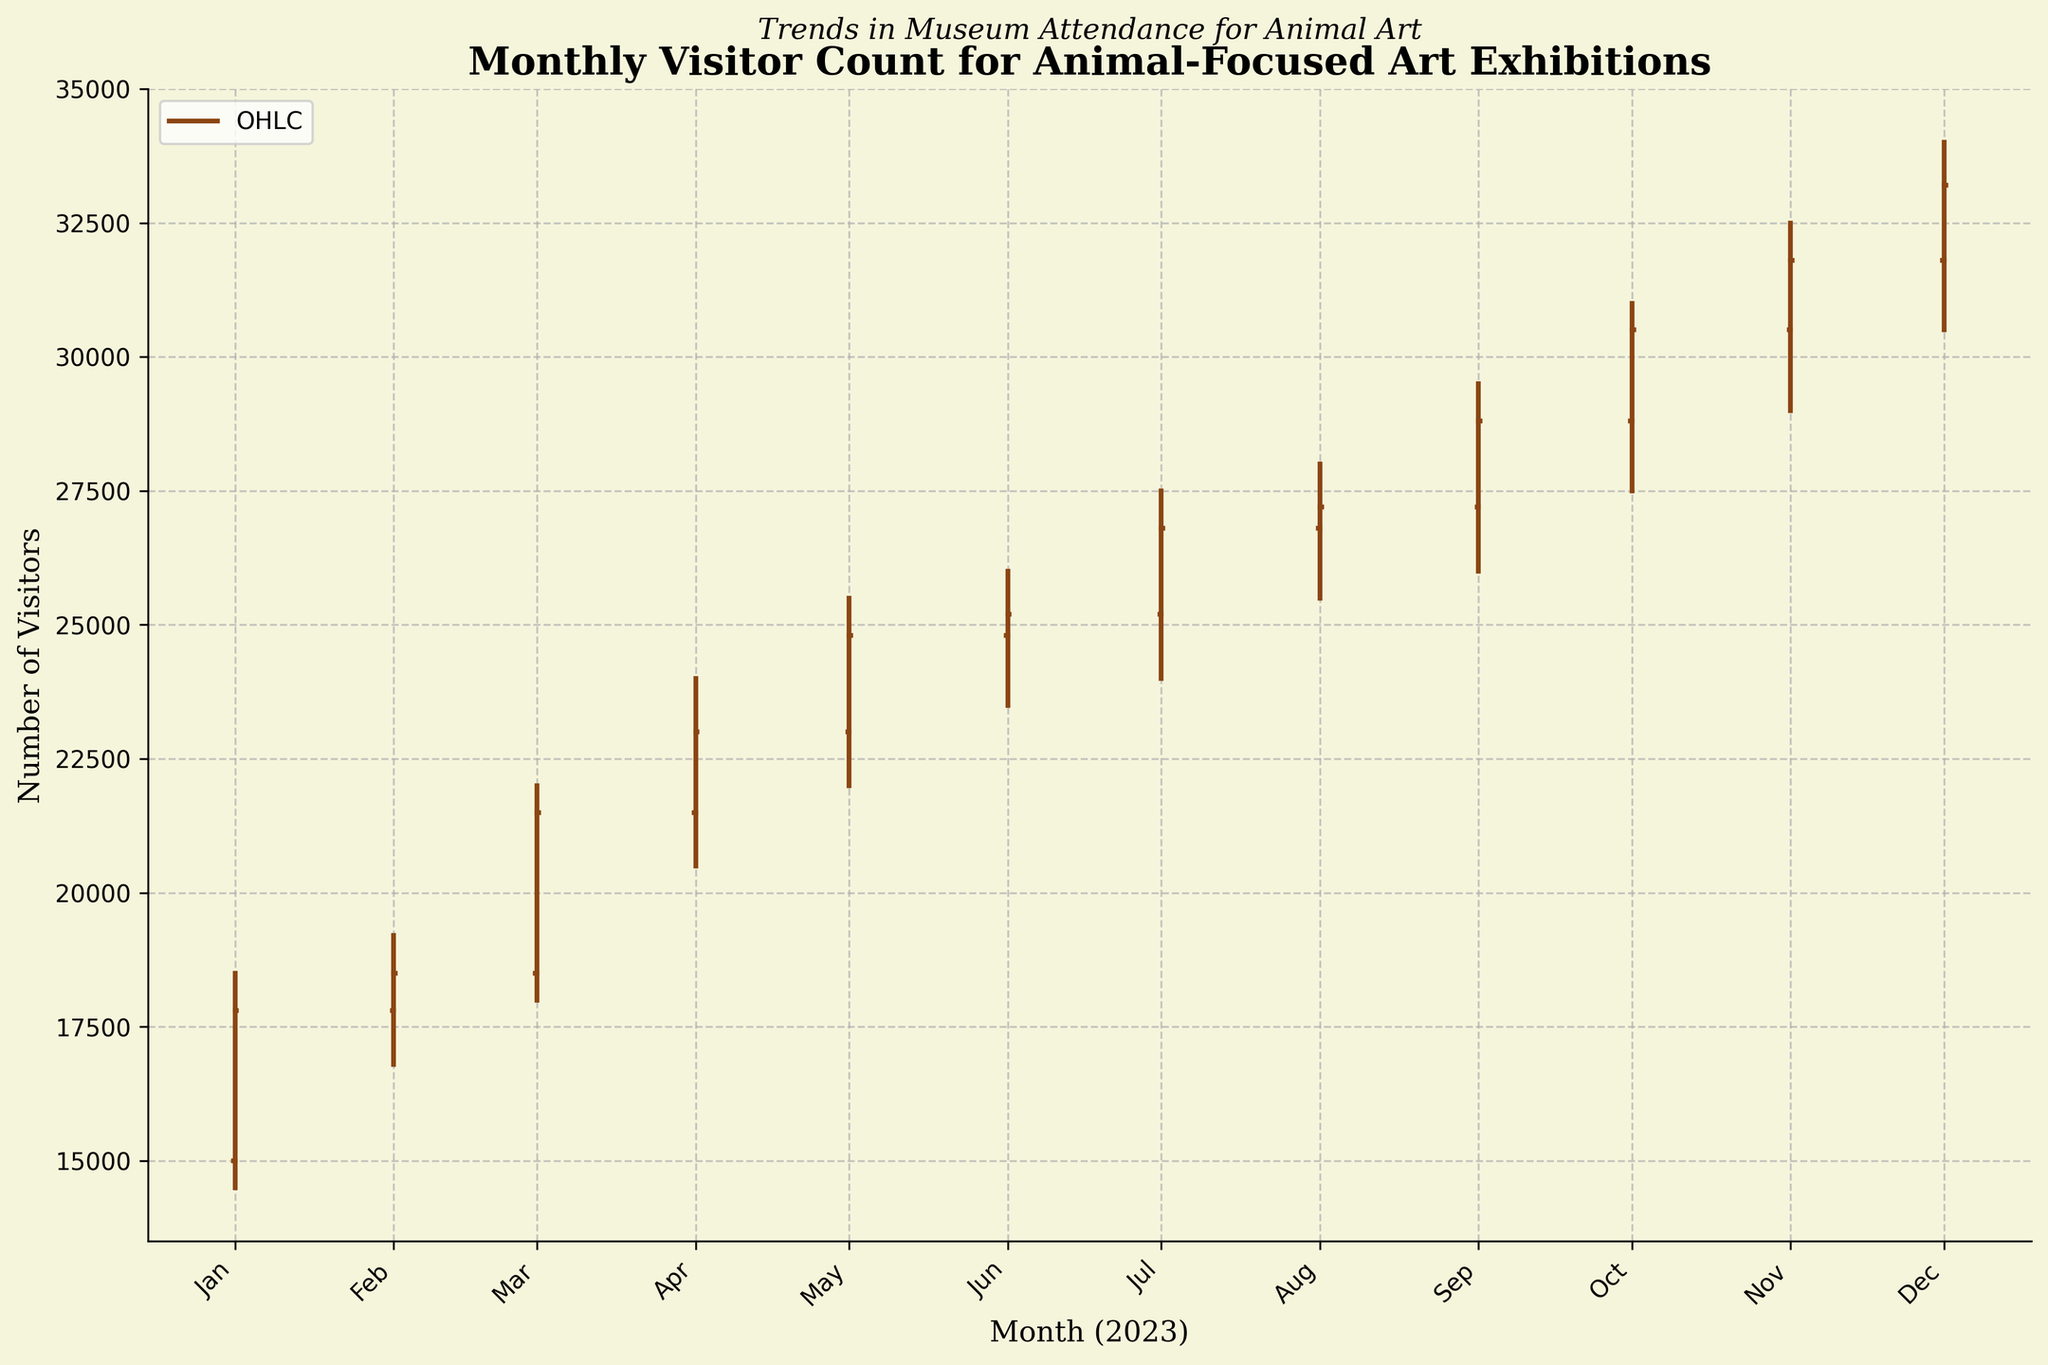What is the title of the figure? The title is usually displayed at the top of the figure, and it provides a brief description of what the figure represents. In this case, it is "Monthly Visitor Count for Animal-Focused Art Exhibitions".
Answer: Monthly Visitor Count for Animal-Focused Art Exhibitions What does the x-axis represent in the figure? The x-axis typically represents the time dimension in monthly OHLC charts. Here, it shows the months of the year 2023.
Answer: Month (2023) What is the highest visitor count recorded in the figure? To find the highest visitor count, look for the highest point in the 'High' column in the data, which corresponds to a High value of 34,000 in December 2023.
Answer: 34,000 Which month had the lowest visitor count and what was the count? To find the lowest visitor count, look for the lowest point in the 'Low' column in the data, which is 14,500 in January 2023.
Answer: January 2023, 14,500 What is the most significant increase in the 'Close' value between two consecutive months? To find this, subtract the 'Close' values of consecutive months and identify the largest difference. The most significant increase is between February and March, where the Close value increased from 18,500 to 21,500, a difference of 3,000.
Answer: 3,000 In which month did the visitor count both open and close at the highest values? Look for the months where the Open and Close values are the highest. December 2023 has the highest values, with an Open of 31,800 and a Close of 33,200.
Answer: December 2023 How does the visitor count in July compare to October? Compare the Open, High, Low, and Close values for July and October. July has values of 25,200 (Open), 27,500 (High), 24,000 (Low), and 26,800 (Close). October has values of 28,800 (Open), 31,000 (High), 27,500 (Low), and 30,500 (Close). Overall, October has higher visitor counts in all aspects.
Answer: October has higher counts What trend is observed in the visitor counts from January to December? By observing the 'Close' values from January to December, it's evident that there's a steady increase in visitor counts over the year, indicating growing interest in animal-focused art exhibitions.
Answer: Steady increase What was the Close value for May, and how did it compare to April? The Close value for May is 24,800, and for April, it is 23,000. By subtracting April's Close from May's Close, the difference is 1,800, indicating an increase.
Answer: 24,800, increase of 1,800 Calculate the average 'Close' value for the entire year. To find the average, sum all 'Close' values and divide by the number of months. (17,800 + 18,500 + 21,500 + 23,000 + 24,800 + 25,200 + 26,800 + 27,200 + 28,800 + 30,500 + 31,800 + 33,200) / 12 = 25,850.
Answer: 25,850 